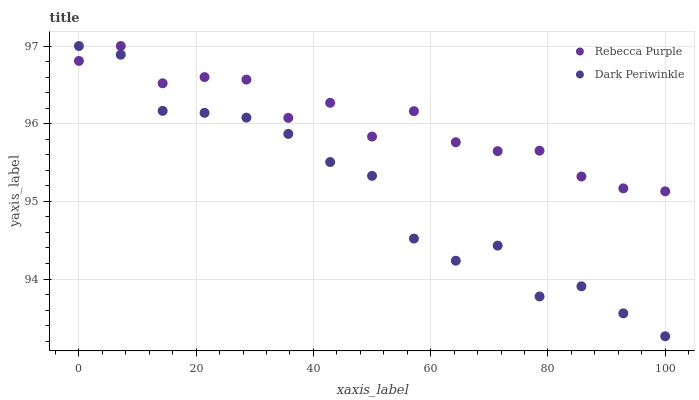Does Dark Periwinkle have the minimum area under the curve?
Answer yes or no. Yes. Does Rebecca Purple have the maximum area under the curve?
Answer yes or no. Yes. Does Dark Periwinkle have the maximum area under the curve?
Answer yes or no. No. Is Dark Periwinkle the smoothest?
Answer yes or no. Yes. Is Rebecca Purple the roughest?
Answer yes or no. Yes. Is Dark Periwinkle the roughest?
Answer yes or no. No. Does Dark Periwinkle have the lowest value?
Answer yes or no. Yes. Does Dark Periwinkle have the highest value?
Answer yes or no. Yes. Does Rebecca Purple intersect Dark Periwinkle?
Answer yes or no. Yes. Is Rebecca Purple less than Dark Periwinkle?
Answer yes or no. No. Is Rebecca Purple greater than Dark Periwinkle?
Answer yes or no. No. 